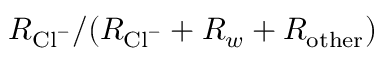<formula> <loc_0><loc_0><loc_500><loc_500>R _ { C l ^ { - } } / ( R _ { C l ^ { - } } + R _ { w } + R _ { o t h e r } )</formula> 